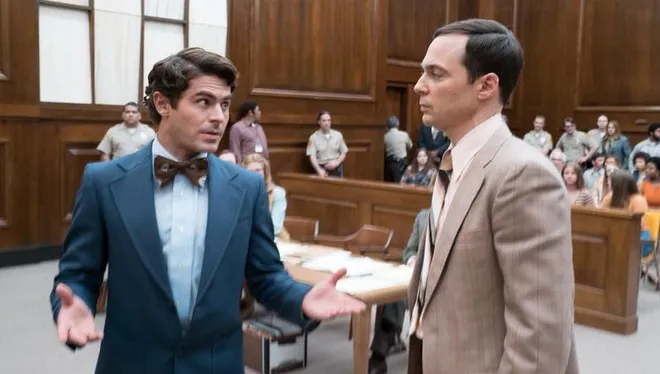Describe the mood in the courtroom based on the people's expressions and posture. The overall mood in the courtroom seems to be one of serious attention and engagement. The main characters show expressions of earnestness and concern, indicative of a high-stakes situation. On the peripheries, the seated individuals display a range of subtle reactions, from anticipation to scrutiny, suggesting that they are closely following the proceedings. The attentive posture of the audience and focused interactions between the central figures suggest an atmosphere charged with tension and the importance of what is being discussed. 